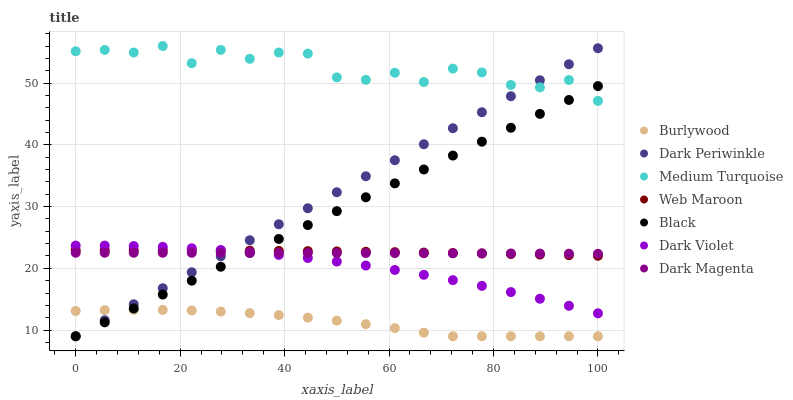Does Burlywood have the minimum area under the curve?
Answer yes or no. Yes. Does Medium Turquoise have the maximum area under the curve?
Answer yes or no. Yes. Does Web Maroon have the minimum area under the curve?
Answer yes or no. No. Does Web Maroon have the maximum area under the curve?
Answer yes or no. No. Is Black the smoothest?
Answer yes or no. Yes. Is Medium Turquoise the roughest?
Answer yes or no. Yes. Is Burlywood the smoothest?
Answer yes or no. No. Is Burlywood the roughest?
Answer yes or no. No. Does Burlywood have the lowest value?
Answer yes or no. Yes. Does Web Maroon have the lowest value?
Answer yes or no. No. Does Medium Turquoise have the highest value?
Answer yes or no. Yes. Does Web Maroon have the highest value?
Answer yes or no. No. Is Burlywood less than Medium Turquoise?
Answer yes or no. Yes. Is Dark Violet greater than Burlywood?
Answer yes or no. Yes. Does Medium Turquoise intersect Black?
Answer yes or no. Yes. Is Medium Turquoise less than Black?
Answer yes or no. No. Is Medium Turquoise greater than Black?
Answer yes or no. No. Does Burlywood intersect Medium Turquoise?
Answer yes or no. No. 